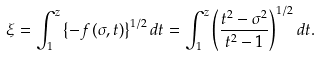Convert formula to latex. <formula><loc_0><loc_0><loc_500><loc_500>\xi = \int _ { 1 } ^ { z } { \left \{ { - f \left ( { \sigma , t } \right ) } \right \} ^ { 1 / 2 } d t } = \int _ { 1 } ^ { z } { \left ( { \frac { t ^ { 2 } - \sigma ^ { 2 } } { t ^ { 2 } - 1 } } \right ) ^ { 1 / 2 } d t } .</formula> 